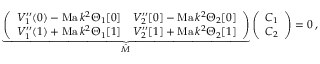Convert formula to latex. <formula><loc_0><loc_0><loc_500><loc_500>\underbrace { \left ( \begin{array} { l l } { V _ { 1 } ^ { \prime \prime } ( 0 ) - M a \, k ^ { 2 } \Theta _ { 1 } [ 0 ] } & { V _ { 2 } ^ { \prime \prime } [ 0 ] - M a \, k ^ { 2 } \Theta _ { 2 } [ 0 ] } \\ { V _ { 1 } ^ { \prime \prime } ( 1 ) + M a \, k ^ { 2 } \Theta _ { 1 } [ 1 ] } & { V _ { 2 } ^ { \prime \prime } [ 1 ] + M a \, k ^ { 2 } \Theta _ { 2 } [ 1 ] } \end{array} \right ) } _ { \hat { M } } \left ( \begin{array} { l } { C _ { 1 } } \\ { C _ { 2 } } \end{array} \right ) = 0 \, ,</formula> 